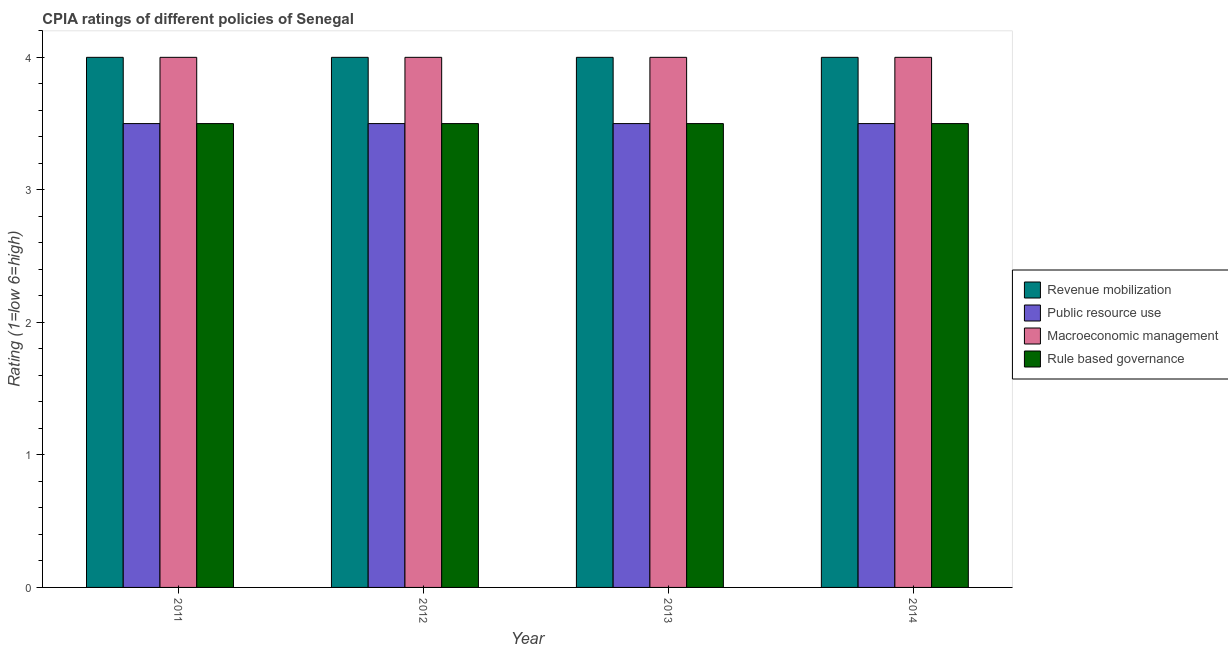Are the number of bars per tick equal to the number of legend labels?
Your answer should be very brief. Yes. How many bars are there on the 1st tick from the left?
Offer a terse response. 4. Across all years, what is the minimum cpia rating of public resource use?
Ensure brevity in your answer.  3.5. What is the total cpia rating of revenue mobilization in the graph?
Keep it short and to the point. 16. What is the difference between the cpia rating of rule based governance in 2012 and that in 2014?
Give a very brief answer. 0. What is the average cpia rating of rule based governance per year?
Provide a short and direct response. 3.5. In the year 2011, what is the difference between the cpia rating of revenue mobilization and cpia rating of public resource use?
Your answer should be compact. 0. In how many years, is the cpia rating of revenue mobilization greater than 1.2?
Offer a very short reply. 4. Is the cpia rating of macroeconomic management in 2011 less than that in 2013?
Your answer should be compact. No. What is the difference between the highest and the second highest cpia rating of rule based governance?
Keep it short and to the point. 0. Is the sum of the cpia rating of rule based governance in 2011 and 2014 greater than the maximum cpia rating of public resource use across all years?
Offer a terse response. Yes. What does the 4th bar from the left in 2011 represents?
Offer a terse response. Rule based governance. What does the 2nd bar from the right in 2013 represents?
Provide a succinct answer. Macroeconomic management. How many bars are there?
Give a very brief answer. 16. Are all the bars in the graph horizontal?
Ensure brevity in your answer.  No. How many years are there in the graph?
Keep it short and to the point. 4. Are the values on the major ticks of Y-axis written in scientific E-notation?
Provide a succinct answer. No. Does the graph contain any zero values?
Ensure brevity in your answer.  No. What is the title of the graph?
Your answer should be compact. CPIA ratings of different policies of Senegal. What is the label or title of the X-axis?
Provide a short and direct response. Year. What is the label or title of the Y-axis?
Offer a very short reply. Rating (1=low 6=high). What is the Rating (1=low 6=high) in Public resource use in 2011?
Your answer should be compact. 3.5. What is the Rating (1=low 6=high) in Macroeconomic management in 2011?
Provide a succinct answer. 4. What is the Rating (1=low 6=high) in Revenue mobilization in 2012?
Your response must be concise. 4. What is the Rating (1=low 6=high) in Rule based governance in 2012?
Offer a very short reply. 3.5. What is the Rating (1=low 6=high) of Public resource use in 2013?
Give a very brief answer. 3.5. What is the Rating (1=low 6=high) of Macroeconomic management in 2013?
Offer a terse response. 4. What is the Rating (1=low 6=high) in Revenue mobilization in 2014?
Provide a short and direct response. 4. What is the Rating (1=low 6=high) in Public resource use in 2014?
Provide a succinct answer. 3.5. What is the Rating (1=low 6=high) in Rule based governance in 2014?
Offer a terse response. 3.5. Across all years, what is the maximum Rating (1=low 6=high) of Revenue mobilization?
Your response must be concise. 4. Across all years, what is the maximum Rating (1=low 6=high) in Public resource use?
Offer a very short reply. 3.5. Across all years, what is the maximum Rating (1=low 6=high) in Macroeconomic management?
Offer a terse response. 4. Across all years, what is the maximum Rating (1=low 6=high) of Rule based governance?
Your response must be concise. 3.5. Across all years, what is the minimum Rating (1=low 6=high) of Macroeconomic management?
Your answer should be very brief. 4. Across all years, what is the minimum Rating (1=low 6=high) of Rule based governance?
Your answer should be compact. 3.5. What is the difference between the Rating (1=low 6=high) in Public resource use in 2011 and that in 2012?
Keep it short and to the point. 0. What is the difference between the Rating (1=low 6=high) of Macroeconomic management in 2011 and that in 2012?
Ensure brevity in your answer.  0. What is the difference between the Rating (1=low 6=high) of Public resource use in 2011 and that in 2013?
Ensure brevity in your answer.  0. What is the difference between the Rating (1=low 6=high) of Macroeconomic management in 2011 and that in 2013?
Give a very brief answer. 0. What is the difference between the Rating (1=low 6=high) of Rule based governance in 2011 and that in 2013?
Give a very brief answer. 0. What is the difference between the Rating (1=low 6=high) in Revenue mobilization in 2011 and that in 2014?
Ensure brevity in your answer.  0. What is the difference between the Rating (1=low 6=high) in Macroeconomic management in 2011 and that in 2014?
Offer a terse response. 0. What is the difference between the Rating (1=low 6=high) in Revenue mobilization in 2012 and that in 2013?
Offer a very short reply. 0. What is the difference between the Rating (1=low 6=high) in Public resource use in 2012 and that in 2013?
Offer a terse response. 0. What is the difference between the Rating (1=low 6=high) of Macroeconomic management in 2012 and that in 2013?
Your response must be concise. 0. What is the difference between the Rating (1=low 6=high) of Revenue mobilization in 2012 and that in 2014?
Your answer should be very brief. 0. What is the difference between the Rating (1=low 6=high) of Revenue mobilization in 2013 and that in 2014?
Your answer should be very brief. 0. What is the difference between the Rating (1=low 6=high) in Rule based governance in 2013 and that in 2014?
Offer a very short reply. 0. What is the difference between the Rating (1=low 6=high) of Revenue mobilization in 2011 and the Rating (1=low 6=high) of Public resource use in 2012?
Keep it short and to the point. 0.5. What is the difference between the Rating (1=low 6=high) of Public resource use in 2011 and the Rating (1=low 6=high) of Macroeconomic management in 2012?
Provide a succinct answer. -0.5. What is the difference between the Rating (1=low 6=high) of Public resource use in 2011 and the Rating (1=low 6=high) of Rule based governance in 2012?
Offer a very short reply. 0. What is the difference between the Rating (1=low 6=high) of Revenue mobilization in 2011 and the Rating (1=low 6=high) of Public resource use in 2013?
Make the answer very short. 0.5. What is the difference between the Rating (1=low 6=high) in Revenue mobilization in 2011 and the Rating (1=low 6=high) in Rule based governance in 2013?
Your answer should be compact. 0.5. What is the difference between the Rating (1=low 6=high) of Public resource use in 2011 and the Rating (1=low 6=high) of Macroeconomic management in 2013?
Your response must be concise. -0.5. What is the difference between the Rating (1=low 6=high) of Revenue mobilization in 2011 and the Rating (1=low 6=high) of Public resource use in 2014?
Your answer should be very brief. 0.5. What is the difference between the Rating (1=low 6=high) of Revenue mobilization in 2011 and the Rating (1=low 6=high) of Rule based governance in 2014?
Your answer should be compact. 0.5. What is the difference between the Rating (1=low 6=high) of Revenue mobilization in 2012 and the Rating (1=low 6=high) of Macroeconomic management in 2013?
Offer a very short reply. 0. What is the difference between the Rating (1=low 6=high) of Public resource use in 2012 and the Rating (1=low 6=high) of Macroeconomic management in 2014?
Offer a terse response. -0.5. What is the difference between the Rating (1=low 6=high) in Public resource use in 2012 and the Rating (1=low 6=high) in Rule based governance in 2014?
Ensure brevity in your answer.  0. What is the difference between the Rating (1=low 6=high) in Public resource use in 2013 and the Rating (1=low 6=high) in Rule based governance in 2014?
Provide a succinct answer. 0. What is the average Rating (1=low 6=high) of Revenue mobilization per year?
Ensure brevity in your answer.  4. What is the average Rating (1=low 6=high) in Public resource use per year?
Make the answer very short. 3.5. What is the average Rating (1=low 6=high) in Macroeconomic management per year?
Offer a terse response. 4. What is the average Rating (1=low 6=high) in Rule based governance per year?
Your answer should be compact. 3.5. In the year 2011, what is the difference between the Rating (1=low 6=high) of Revenue mobilization and Rating (1=low 6=high) of Public resource use?
Your answer should be compact. 0.5. In the year 2011, what is the difference between the Rating (1=low 6=high) in Revenue mobilization and Rating (1=low 6=high) in Macroeconomic management?
Provide a short and direct response. 0. In the year 2011, what is the difference between the Rating (1=low 6=high) in Revenue mobilization and Rating (1=low 6=high) in Rule based governance?
Keep it short and to the point. 0.5. In the year 2011, what is the difference between the Rating (1=low 6=high) of Public resource use and Rating (1=low 6=high) of Rule based governance?
Offer a terse response. 0. In the year 2011, what is the difference between the Rating (1=low 6=high) of Macroeconomic management and Rating (1=low 6=high) of Rule based governance?
Your response must be concise. 0.5. In the year 2012, what is the difference between the Rating (1=low 6=high) of Revenue mobilization and Rating (1=low 6=high) of Rule based governance?
Your answer should be compact. 0.5. In the year 2012, what is the difference between the Rating (1=low 6=high) of Macroeconomic management and Rating (1=low 6=high) of Rule based governance?
Provide a short and direct response. 0.5. In the year 2013, what is the difference between the Rating (1=low 6=high) in Revenue mobilization and Rating (1=low 6=high) in Public resource use?
Your response must be concise. 0.5. In the year 2013, what is the difference between the Rating (1=low 6=high) of Revenue mobilization and Rating (1=low 6=high) of Rule based governance?
Offer a terse response. 0.5. In the year 2013, what is the difference between the Rating (1=low 6=high) in Public resource use and Rating (1=low 6=high) in Macroeconomic management?
Provide a short and direct response. -0.5. In the year 2014, what is the difference between the Rating (1=low 6=high) of Revenue mobilization and Rating (1=low 6=high) of Public resource use?
Your answer should be compact. 0.5. What is the ratio of the Rating (1=low 6=high) of Public resource use in 2011 to that in 2012?
Your answer should be very brief. 1. What is the ratio of the Rating (1=low 6=high) of Macroeconomic management in 2011 to that in 2012?
Keep it short and to the point. 1. What is the ratio of the Rating (1=low 6=high) of Public resource use in 2011 to that in 2014?
Make the answer very short. 1. What is the ratio of the Rating (1=low 6=high) in Macroeconomic management in 2011 to that in 2014?
Your answer should be very brief. 1. What is the ratio of the Rating (1=low 6=high) of Rule based governance in 2011 to that in 2014?
Offer a terse response. 1. What is the ratio of the Rating (1=low 6=high) of Revenue mobilization in 2012 to that in 2013?
Ensure brevity in your answer.  1. What is the ratio of the Rating (1=low 6=high) of Rule based governance in 2012 to that in 2013?
Ensure brevity in your answer.  1. What is the ratio of the Rating (1=low 6=high) of Rule based governance in 2012 to that in 2014?
Offer a terse response. 1. What is the ratio of the Rating (1=low 6=high) in Public resource use in 2013 to that in 2014?
Offer a very short reply. 1. What is the difference between the highest and the second highest Rating (1=low 6=high) in Revenue mobilization?
Keep it short and to the point. 0. What is the difference between the highest and the lowest Rating (1=low 6=high) in Revenue mobilization?
Your answer should be very brief. 0. What is the difference between the highest and the lowest Rating (1=low 6=high) of Macroeconomic management?
Provide a succinct answer. 0. 